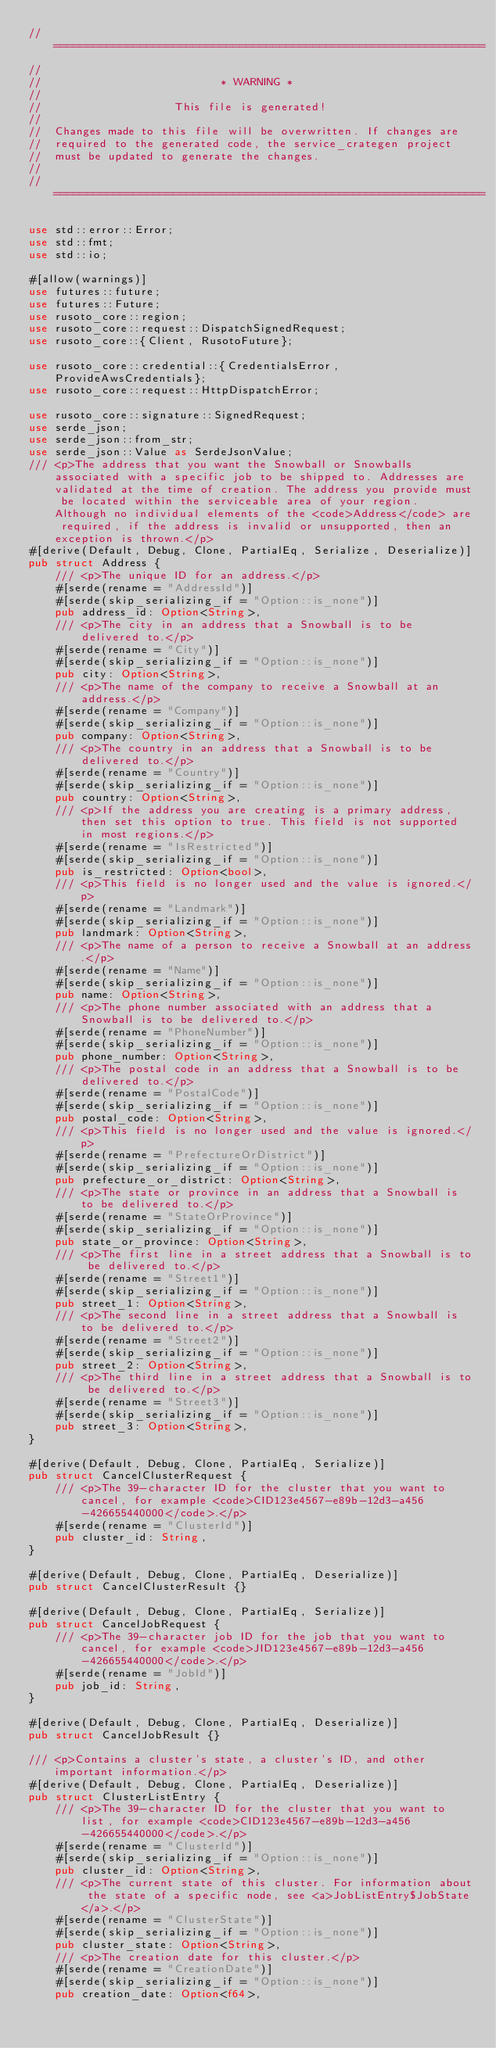Convert code to text. <code><loc_0><loc_0><loc_500><loc_500><_Rust_>// =================================================================
//
//                           * WARNING *
//
//                    This file is generated!
//
//  Changes made to this file will be overwritten. If changes are
//  required to the generated code, the service_crategen project
//  must be updated to generate the changes.
//
// =================================================================

use std::error::Error;
use std::fmt;
use std::io;

#[allow(warnings)]
use futures::future;
use futures::Future;
use rusoto_core::region;
use rusoto_core::request::DispatchSignedRequest;
use rusoto_core::{Client, RusotoFuture};

use rusoto_core::credential::{CredentialsError, ProvideAwsCredentials};
use rusoto_core::request::HttpDispatchError;

use rusoto_core::signature::SignedRequest;
use serde_json;
use serde_json::from_str;
use serde_json::Value as SerdeJsonValue;
/// <p>The address that you want the Snowball or Snowballs associated with a specific job to be shipped to. Addresses are validated at the time of creation. The address you provide must be located within the serviceable area of your region. Although no individual elements of the <code>Address</code> are required, if the address is invalid or unsupported, then an exception is thrown.</p>
#[derive(Default, Debug, Clone, PartialEq, Serialize, Deserialize)]
pub struct Address {
    /// <p>The unique ID for an address.</p>
    #[serde(rename = "AddressId")]
    #[serde(skip_serializing_if = "Option::is_none")]
    pub address_id: Option<String>,
    /// <p>The city in an address that a Snowball is to be delivered to.</p>
    #[serde(rename = "City")]
    #[serde(skip_serializing_if = "Option::is_none")]
    pub city: Option<String>,
    /// <p>The name of the company to receive a Snowball at an address.</p>
    #[serde(rename = "Company")]
    #[serde(skip_serializing_if = "Option::is_none")]
    pub company: Option<String>,
    /// <p>The country in an address that a Snowball is to be delivered to.</p>
    #[serde(rename = "Country")]
    #[serde(skip_serializing_if = "Option::is_none")]
    pub country: Option<String>,
    /// <p>If the address you are creating is a primary address, then set this option to true. This field is not supported in most regions.</p>
    #[serde(rename = "IsRestricted")]
    #[serde(skip_serializing_if = "Option::is_none")]
    pub is_restricted: Option<bool>,
    /// <p>This field is no longer used and the value is ignored.</p>
    #[serde(rename = "Landmark")]
    #[serde(skip_serializing_if = "Option::is_none")]
    pub landmark: Option<String>,
    /// <p>The name of a person to receive a Snowball at an address.</p>
    #[serde(rename = "Name")]
    #[serde(skip_serializing_if = "Option::is_none")]
    pub name: Option<String>,
    /// <p>The phone number associated with an address that a Snowball is to be delivered to.</p>
    #[serde(rename = "PhoneNumber")]
    #[serde(skip_serializing_if = "Option::is_none")]
    pub phone_number: Option<String>,
    /// <p>The postal code in an address that a Snowball is to be delivered to.</p>
    #[serde(rename = "PostalCode")]
    #[serde(skip_serializing_if = "Option::is_none")]
    pub postal_code: Option<String>,
    /// <p>This field is no longer used and the value is ignored.</p>
    #[serde(rename = "PrefectureOrDistrict")]
    #[serde(skip_serializing_if = "Option::is_none")]
    pub prefecture_or_district: Option<String>,
    /// <p>The state or province in an address that a Snowball is to be delivered to.</p>
    #[serde(rename = "StateOrProvince")]
    #[serde(skip_serializing_if = "Option::is_none")]
    pub state_or_province: Option<String>,
    /// <p>The first line in a street address that a Snowball is to be delivered to.</p>
    #[serde(rename = "Street1")]
    #[serde(skip_serializing_if = "Option::is_none")]
    pub street_1: Option<String>,
    /// <p>The second line in a street address that a Snowball is to be delivered to.</p>
    #[serde(rename = "Street2")]
    #[serde(skip_serializing_if = "Option::is_none")]
    pub street_2: Option<String>,
    /// <p>The third line in a street address that a Snowball is to be delivered to.</p>
    #[serde(rename = "Street3")]
    #[serde(skip_serializing_if = "Option::is_none")]
    pub street_3: Option<String>,
}

#[derive(Default, Debug, Clone, PartialEq, Serialize)]
pub struct CancelClusterRequest {
    /// <p>The 39-character ID for the cluster that you want to cancel, for example <code>CID123e4567-e89b-12d3-a456-426655440000</code>.</p>
    #[serde(rename = "ClusterId")]
    pub cluster_id: String,
}

#[derive(Default, Debug, Clone, PartialEq, Deserialize)]
pub struct CancelClusterResult {}

#[derive(Default, Debug, Clone, PartialEq, Serialize)]
pub struct CancelJobRequest {
    /// <p>The 39-character job ID for the job that you want to cancel, for example <code>JID123e4567-e89b-12d3-a456-426655440000</code>.</p>
    #[serde(rename = "JobId")]
    pub job_id: String,
}

#[derive(Default, Debug, Clone, PartialEq, Deserialize)]
pub struct CancelJobResult {}

/// <p>Contains a cluster's state, a cluster's ID, and other important information.</p>
#[derive(Default, Debug, Clone, PartialEq, Deserialize)]
pub struct ClusterListEntry {
    /// <p>The 39-character ID for the cluster that you want to list, for example <code>CID123e4567-e89b-12d3-a456-426655440000</code>.</p>
    #[serde(rename = "ClusterId")]
    #[serde(skip_serializing_if = "Option::is_none")]
    pub cluster_id: Option<String>,
    /// <p>The current state of this cluster. For information about the state of a specific node, see <a>JobListEntry$JobState</a>.</p>
    #[serde(rename = "ClusterState")]
    #[serde(skip_serializing_if = "Option::is_none")]
    pub cluster_state: Option<String>,
    /// <p>The creation date for this cluster.</p>
    #[serde(rename = "CreationDate")]
    #[serde(skip_serializing_if = "Option::is_none")]
    pub creation_date: Option<f64>,</code> 